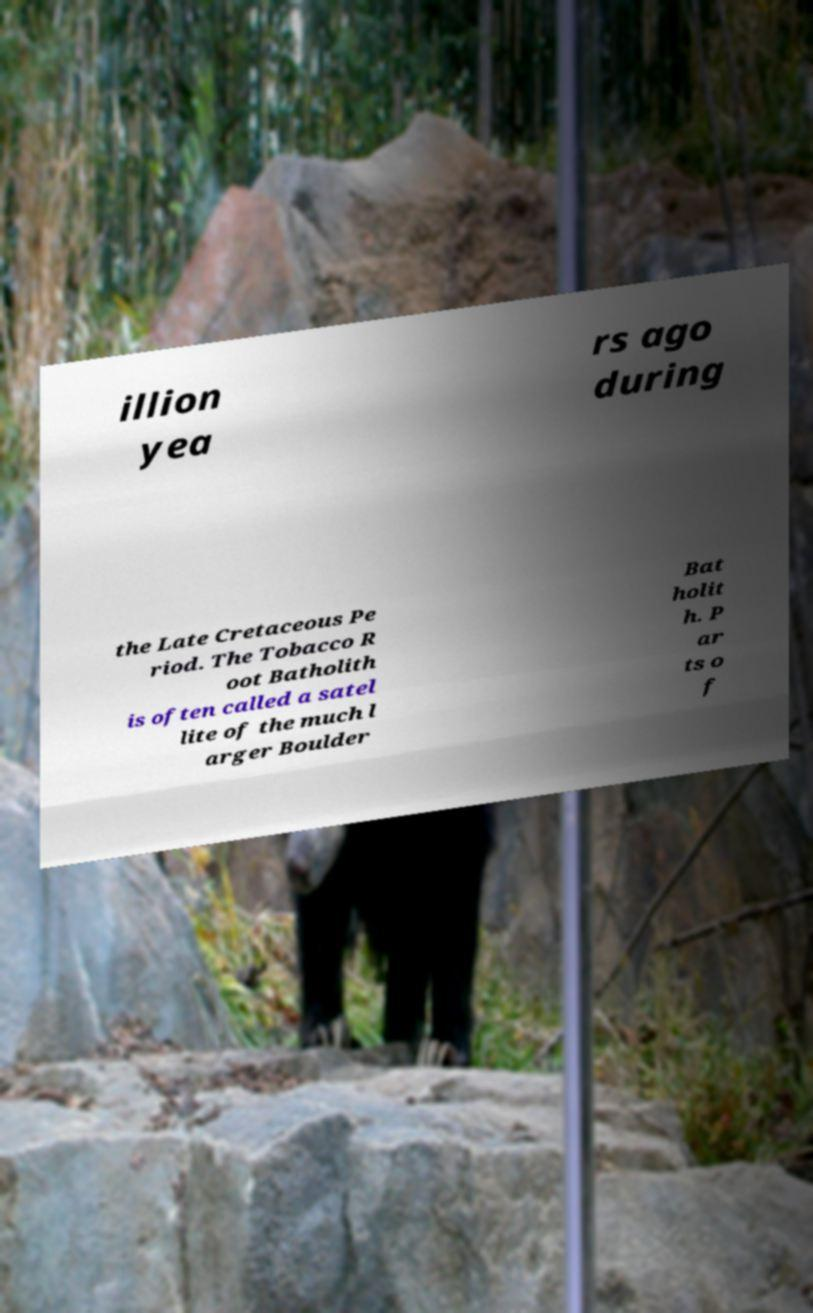Please identify and transcribe the text found in this image. illion yea rs ago during the Late Cretaceous Pe riod. The Tobacco R oot Batholith is often called a satel lite of the much l arger Boulder Bat holit h. P ar ts o f 